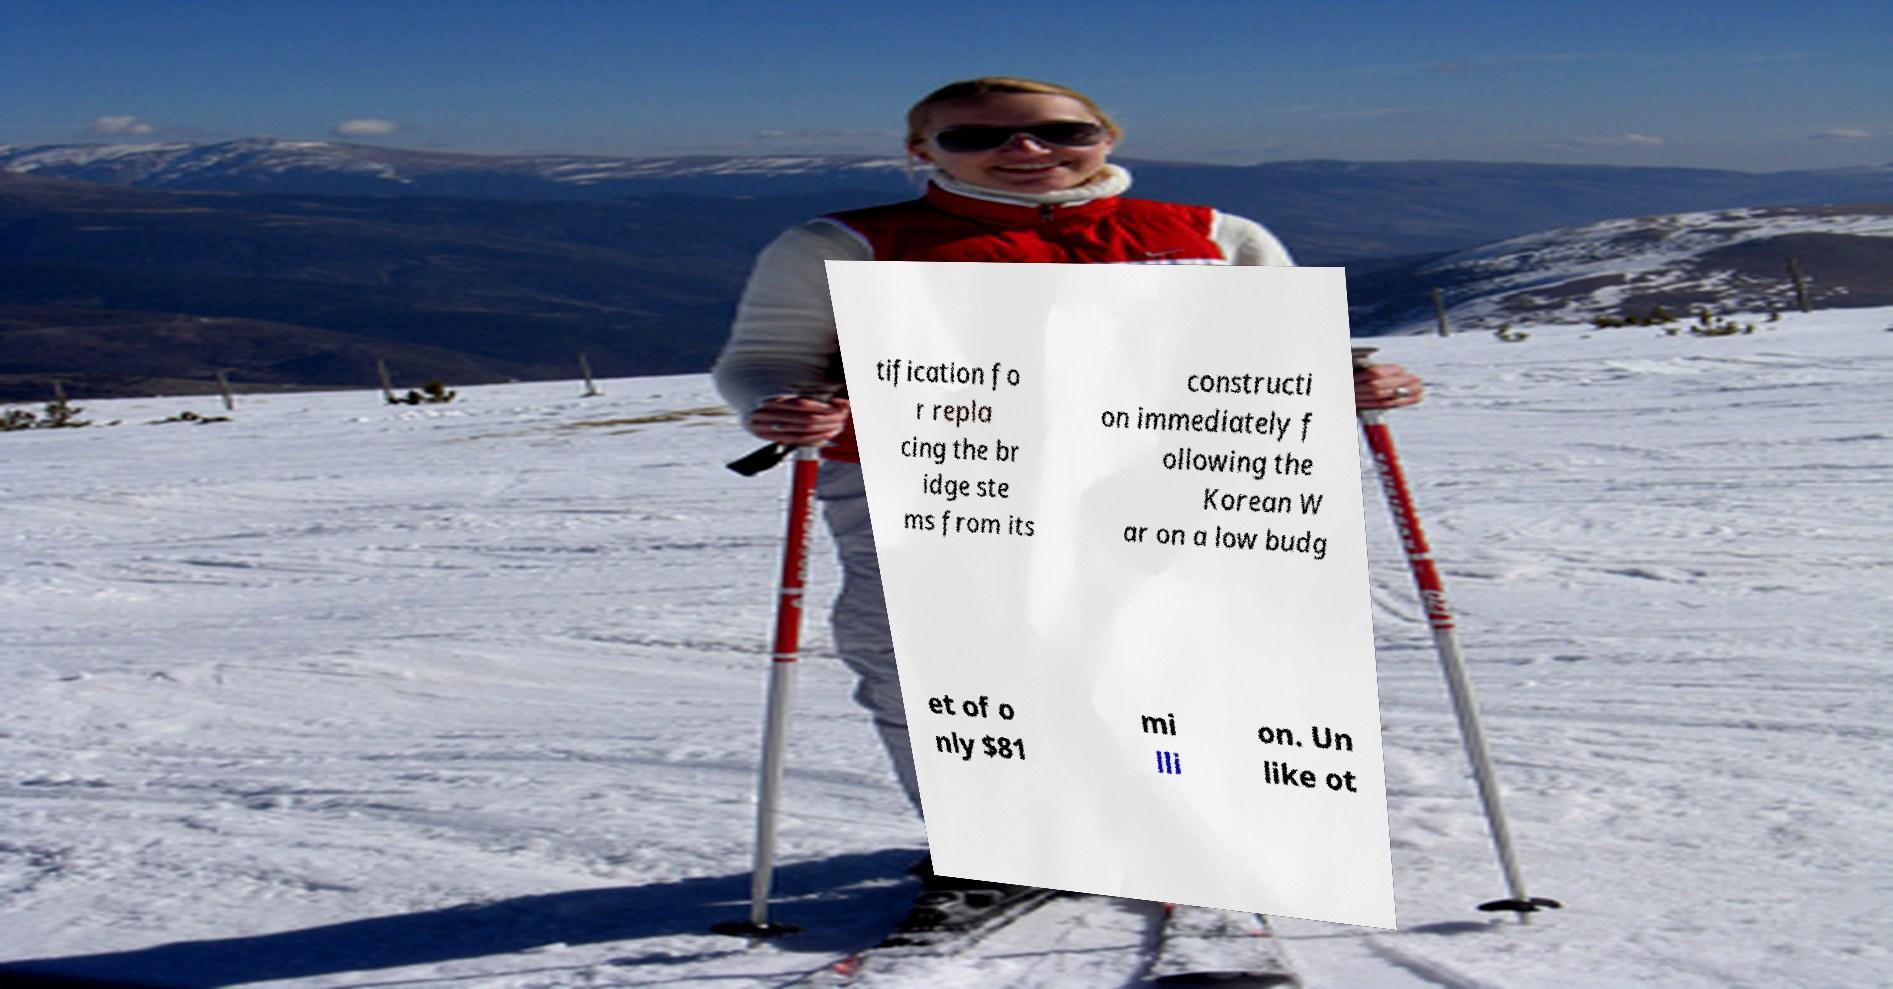Could you assist in decoding the text presented in this image and type it out clearly? tification fo r repla cing the br idge ste ms from its constructi on immediately f ollowing the Korean W ar on a low budg et of o nly $81 mi lli on. Un like ot 